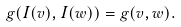Convert formula to latex. <formula><loc_0><loc_0><loc_500><loc_500>g ( I ( v ) , I ( w ) ) = g ( v , w ) .</formula> 